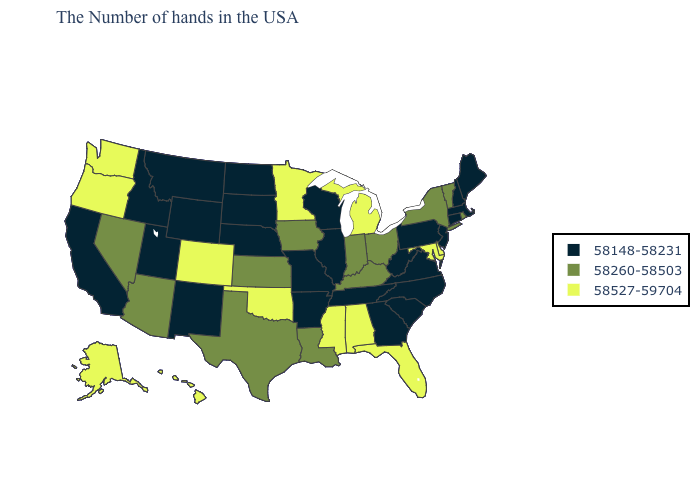What is the value of Vermont?
Short answer required. 58260-58503. What is the highest value in the USA?
Answer briefly. 58527-59704. What is the value of California?
Quick response, please. 58148-58231. Name the states that have a value in the range 58527-59704?
Give a very brief answer. Delaware, Maryland, Florida, Michigan, Alabama, Mississippi, Minnesota, Oklahoma, Colorado, Washington, Oregon, Alaska, Hawaii. Among the states that border Utah , does Nevada have the lowest value?
Give a very brief answer. No. Which states have the lowest value in the South?
Be succinct. Virginia, North Carolina, South Carolina, West Virginia, Georgia, Tennessee, Arkansas. What is the highest value in states that border Washington?
Write a very short answer. 58527-59704. Does the first symbol in the legend represent the smallest category?
Write a very short answer. Yes. Name the states that have a value in the range 58148-58231?
Be succinct. Maine, Massachusetts, New Hampshire, Connecticut, New Jersey, Pennsylvania, Virginia, North Carolina, South Carolina, West Virginia, Georgia, Tennessee, Wisconsin, Illinois, Missouri, Arkansas, Nebraska, South Dakota, North Dakota, Wyoming, New Mexico, Utah, Montana, Idaho, California. What is the value of Massachusetts?
Keep it brief. 58148-58231. Name the states that have a value in the range 58260-58503?
Answer briefly. Rhode Island, Vermont, New York, Ohio, Kentucky, Indiana, Louisiana, Iowa, Kansas, Texas, Arizona, Nevada. What is the value of South Carolina?
Short answer required. 58148-58231. Name the states that have a value in the range 58260-58503?
Give a very brief answer. Rhode Island, Vermont, New York, Ohio, Kentucky, Indiana, Louisiana, Iowa, Kansas, Texas, Arizona, Nevada. Name the states that have a value in the range 58260-58503?
Short answer required. Rhode Island, Vermont, New York, Ohio, Kentucky, Indiana, Louisiana, Iowa, Kansas, Texas, Arizona, Nevada. Does the map have missing data?
Give a very brief answer. No. 